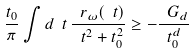<formula> <loc_0><loc_0><loc_500><loc_500>\frac { t _ { 0 } } { \pi } \int d \ t \, \frac { \ r _ { \omega } ( \ t ) } { \ t ^ { 2 } + t _ { 0 } ^ { 2 } } \geq - \frac { \ G _ { d } } { t _ { 0 } ^ { d } }</formula> 